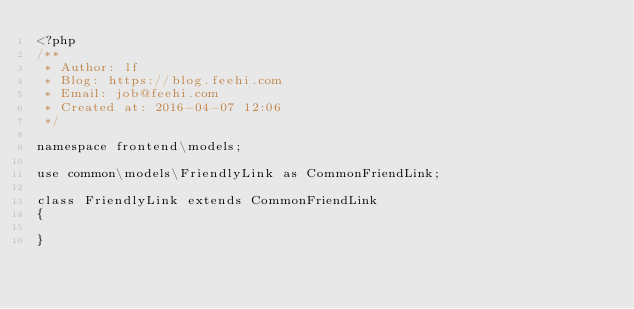<code> <loc_0><loc_0><loc_500><loc_500><_PHP_><?php
/**
 * Author: lf
 * Blog: https://blog.feehi.com
 * Email: job@feehi.com
 * Created at: 2016-04-07 12:06
 */

namespace frontend\models;

use common\models\FriendlyLink as CommonFriendLink;

class FriendlyLink extends CommonFriendLink
{

}</code> 